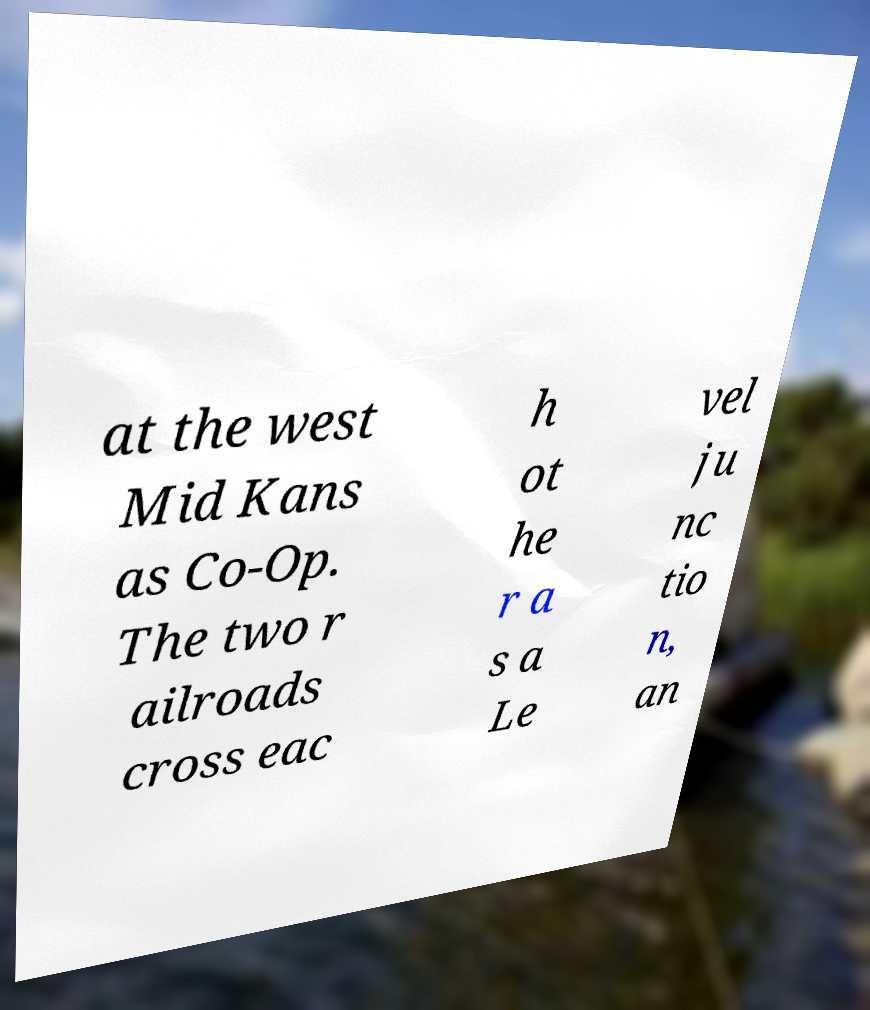I need the written content from this picture converted into text. Can you do that? at the west Mid Kans as Co-Op. The two r ailroads cross eac h ot he r a s a Le vel ju nc tio n, an 